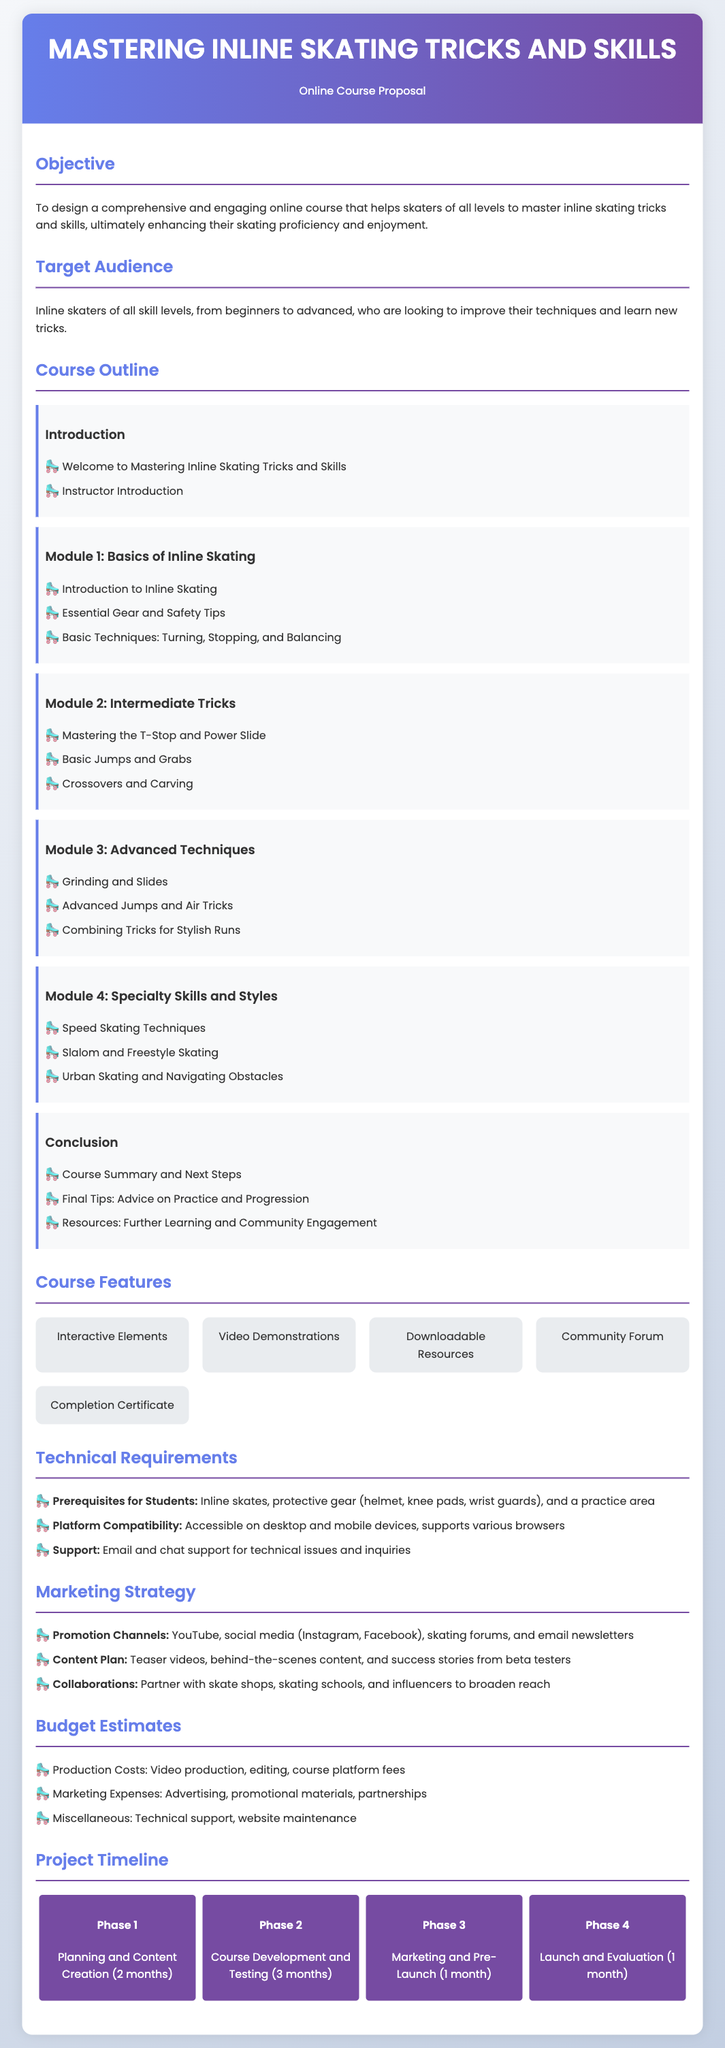What is the objective of the course? The objective is to design a comprehensive and engaging online course that helps skaters of all levels to master inline skating tricks and skills.
Answer: To design a comprehensive and engaging online course that helps skaters of all levels to master inline skating tricks and skills Who is the target audience for the course? The target audience is defined in the document as a specific group of individuals.
Answer: Inline skaters of all skill levels What is included in Module 2? The document lists specific topics covered in Module 2, which are focused on intermediate skills.
Answer: Mastering the T-Stop and Power Slide, Basic Jumps and Grabs, Crossovers and Carving How many phases are in the project timeline? The number of phases mentioned in the timeline section of the proposal gives insight into project planning.
Answer: Four phases Which interactive elements are featured in the course? The proposal outlines several features designed to enhance the learning experience.
Answer: Interactive Elements, Video Demonstrations, Downloadable Resources, Community Forum, Completion Certificate What is the duration for planning and content creation? The timeline section specifies the time allocated for this phase of the project.
Answer: Two months What platforms will the course be accessible on? The technical requirements include information regarding platform compatibility.
Answer: Desktop and mobile devices What marketing channels will be used for promotion? The document lists specific channels intended for marketing the course.
Answer: YouTube, social media, skating forums, email newsletters 